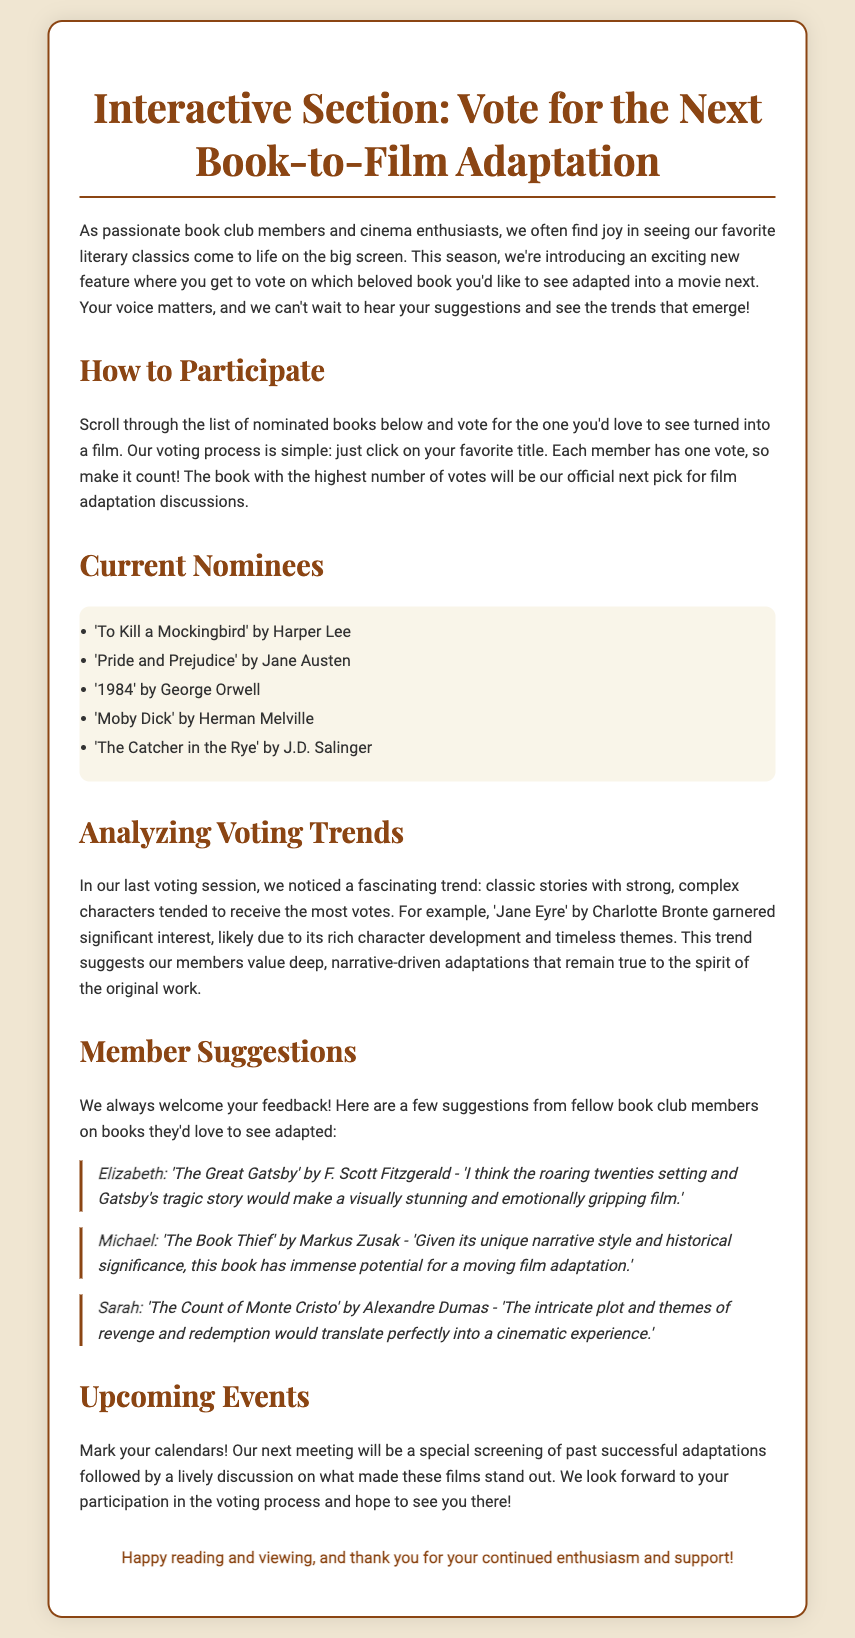What are the current nominees? The document lists the nominated books under the "Current Nominees" section.
Answer: 'To Kill a Mockingbird', 'Pride and Prejudice', '1984', 'Moby Dick', 'The Catcher in the Rye' Who suggested 'The Great Gatsby'? The suggestion is attributed to a member named Elizabeth in the "Member Suggestions" section.
Answer: Elizabeth How many books can each member vote for? The document outlines the voting process, indicating members have a limit.
Answer: One What trend was observed in the last voting session? The document discusses a trend regarding the types of stories that received the most votes.
Answer: Strong, complex characters What will the next meeting feature? The document states what will be highlighted in the upcoming event for members.
Answer: A special screening of past successful adaptations 